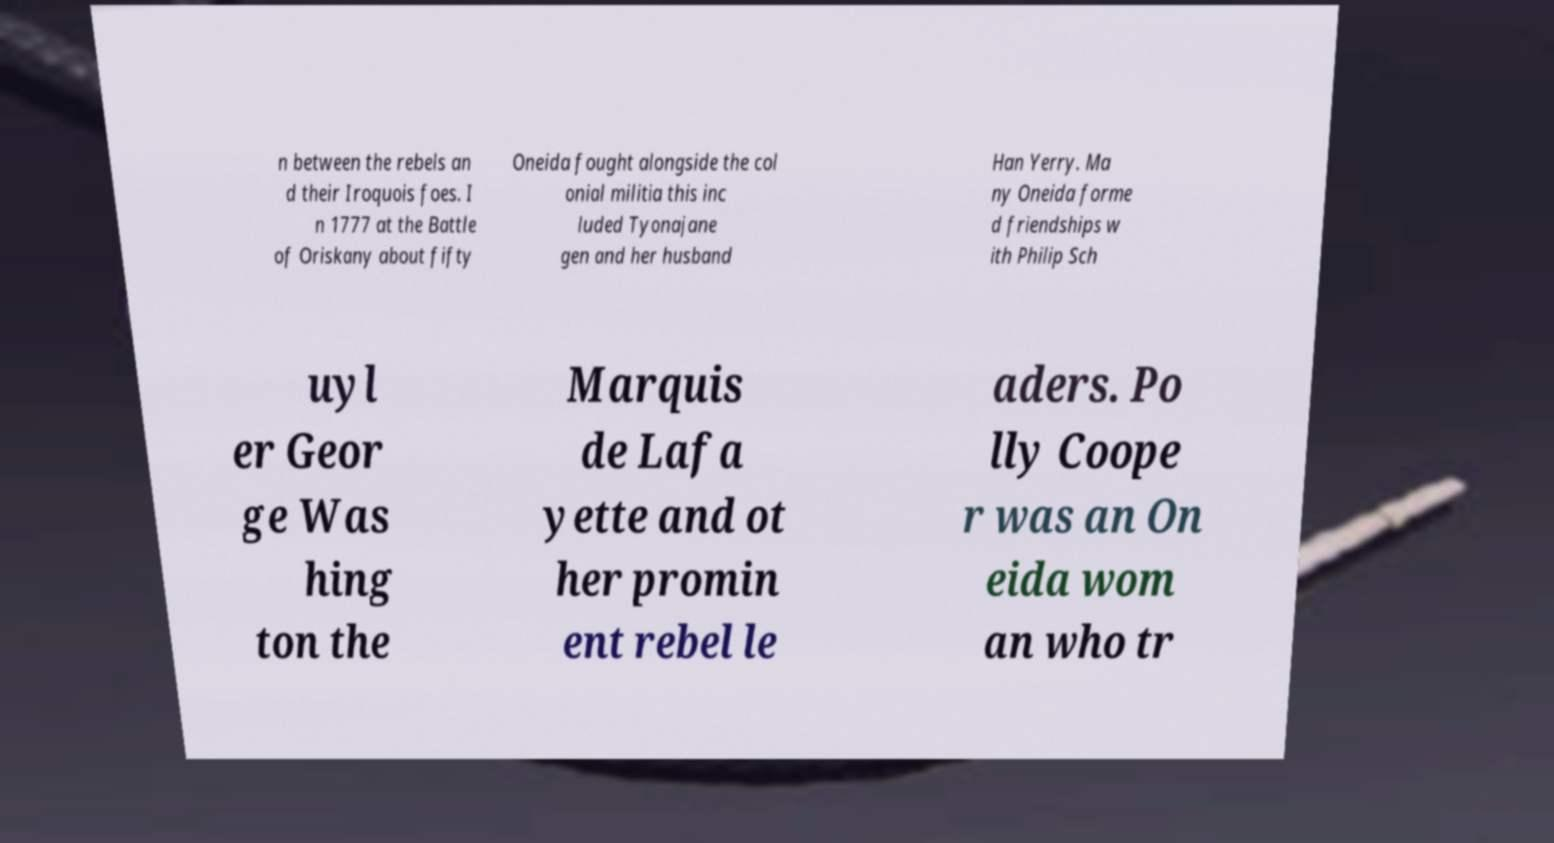There's text embedded in this image that I need extracted. Can you transcribe it verbatim? n between the rebels an d their Iroquois foes. I n 1777 at the Battle of Oriskany about fifty Oneida fought alongside the col onial militia this inc luded Tyonajane gen and her husband Han Yerry. Ma ny Oneida forme d friendships w ith Philip Sch uyl er Geor ge Was hing ton the Marquis de Lafa yette and ot her promin ent rebel le aders. Po lly Coope r was an On eida wom an who tr 